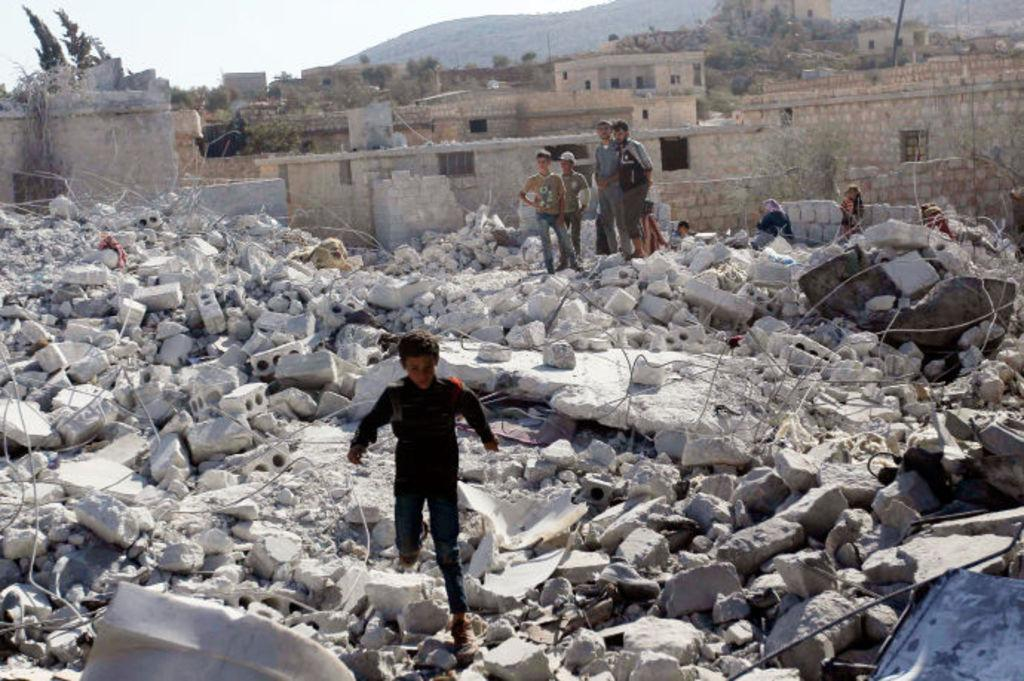What is the main subject of the image? The main subject of the image is a collapsed building. What is the person in the image doing? The person is standing on the bricks of the collapsed building. What can be seen in the background of the image? There are buildings, trees, a mountain, and the sky visible in the background of the image. What type of fact can be seen being rewarded in the image? There is no fact or reward being depicted in the image; it shows a collapsed building and a person standing on the bricks. What is the porter carrying in the image? There is no porter present in the image. 